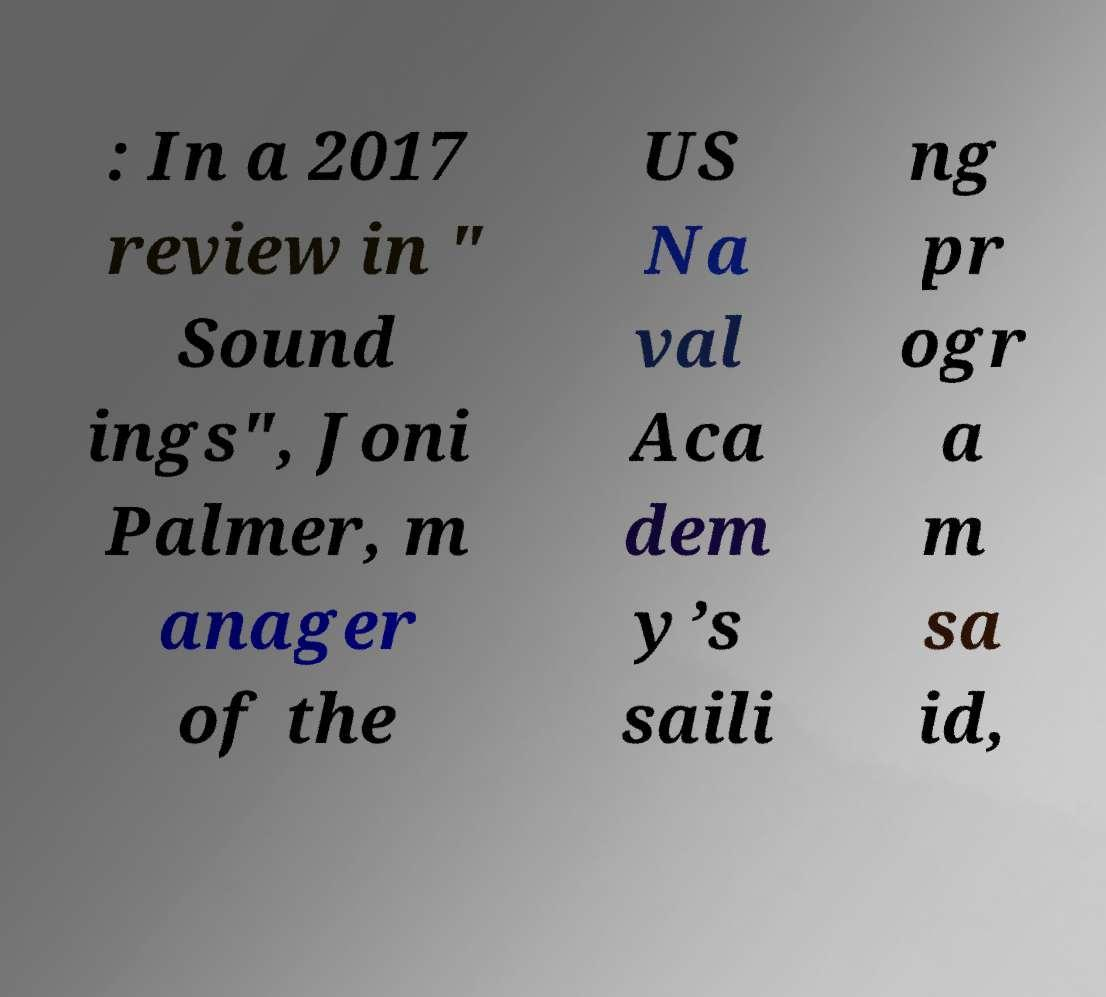Please identify and transcribe the text found in this image. : In a 2017 review in " Sound ings", Joni Palmer, m anager of the US Na val Aca dem y’s saili ng pr ogr a m sa id, 